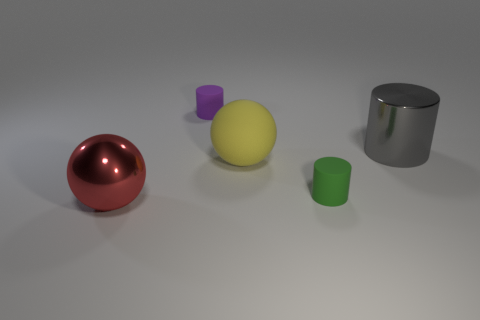Can you describe the objects in terms of their shapes and materials? Certainly! The image displays a collection of objects that vary in shape and material. From left to right: a glossy red sphere, which appears to be made of rubber; a matte yellow sphere, likely plastic; a purple cylinder, possibly plastic or metal; a green cylinder, similar in texture to the purple; and a shiny blue cylinder, which seems metallic. 